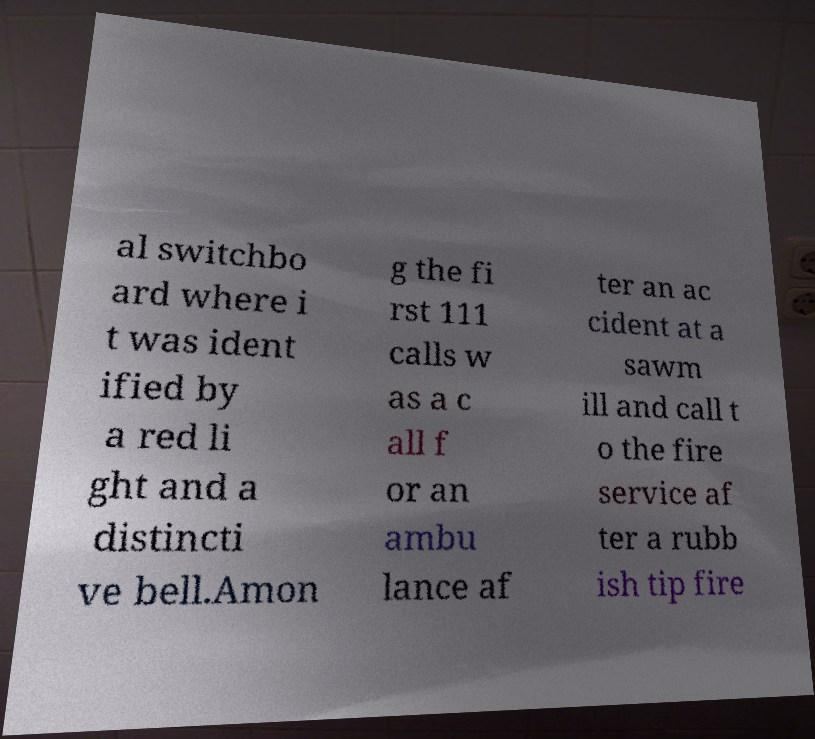Could you extract and type out the text from this image? al switchbo ard where i t was ident ified by a red li ght and a distincti ve bell.Amon g the fi rst 111 calls w as a c all f or an ambu lance af ter an ac cident at a sawm ill and call t o the fire service af ter a rubb ish tip fire 